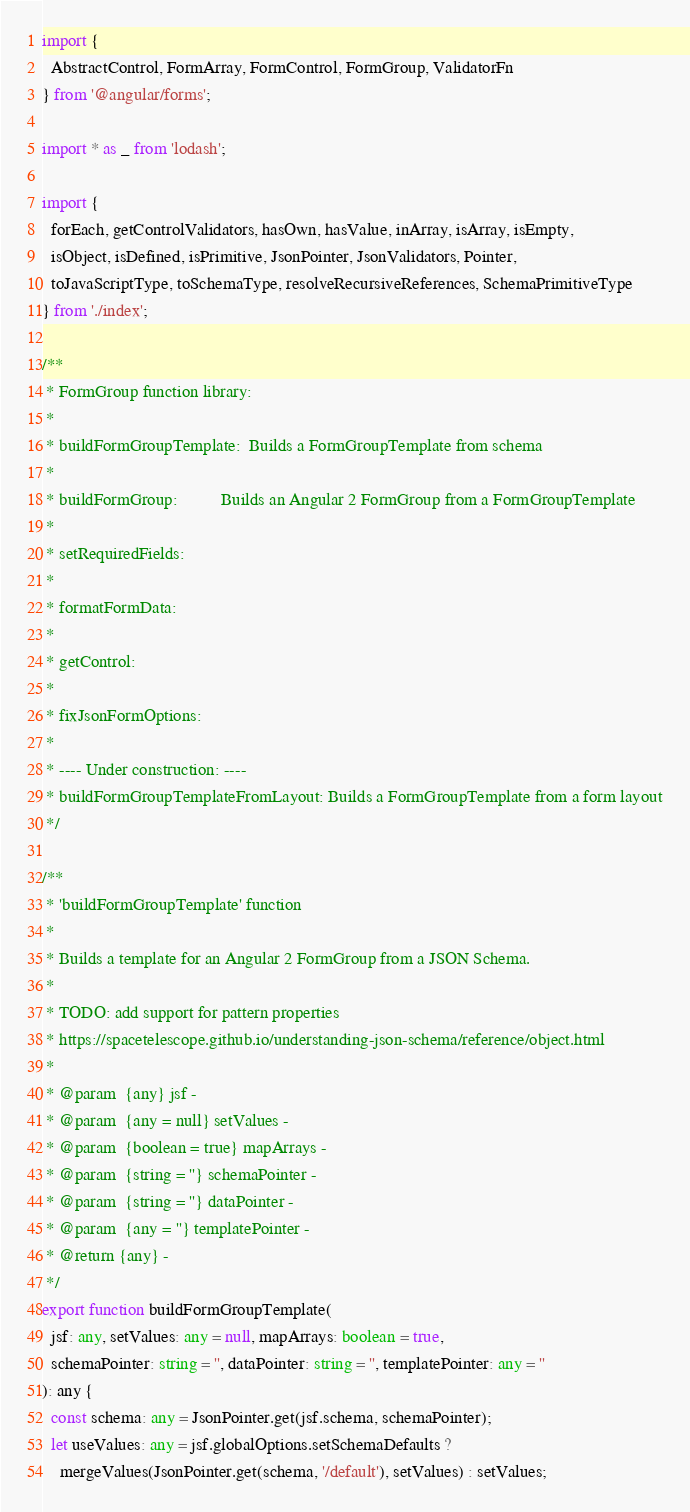Convert code to text. <code><loc_0><loc_0><loc_500><loc_500><_TypeScript_>import {
  AbstractControl, FormArray, FormControl, FormGroup, ValidatorFn
} from '@angular/forms';

import * as _ from 'lodash';

import {
  forEach, getControlValidators, hasOwn, hasValue, inArray, isArray, isEmpty,
  isObject, isDefined, isPrimitive, JsonPointer, JsonValidators, Pointer,
  toJavaScriptType, toSchemaType, resolveRecursiveReferences, SchemaPrimitiveType
} from './index';

/**
 * FormGroup function library:
 *
 * buildFormGroupTemplate:  Builds a FormGroupTemplate from schema
 *
 * buildFormGroup:          Builds an Angular 2 FormGroup from a FormGroupTemplate
 *
 * setRequiredFields:
 *
 * formatFormData:
 *
 * getControl:
 *
 * fixJsonFormOptions:
 *
 * ---- Under construction: ----
 * buildFormGroupTemplateFromLayout: Builds a FormGroupTemplate from a form layout
 */

/**
 * 'buildFormGroupTemplate' function
 *
 * Builds a template for an Angular 2 FormGroup from a JSON Schema.
 *
 * TODO: add support for pattern properties
 * https://spacetelescope.github.io/understanding-json-schema/reference/object.html
 *
 * @param  {any} jsf -
 * @param  {any = null} setValues -
 * @param  {boolean = true} mapArrays -
 * @param  {string = ''} schemaPointer -
 * @param  {string = ''} dataPointer -
 * @param  {any = ''} templatePointer -
 * @return {any} -
 */
export function buildFormGroupTemplate(
  jsf: any, setValues: any = null, mapArrays: boolean = true,
  schemaPointer: string = '', dataPointer: string = '', templatePointer: any = ''
): any {
  const schema: any = JsonPointer.get(jsf.schema, schemaPointer);
  let useValues: any = jsf.globalOptions.setSchemaDefaults ?
    mergeValues(JsonPointer.get(schema, '/default'), setValues) : setValues;</code> 